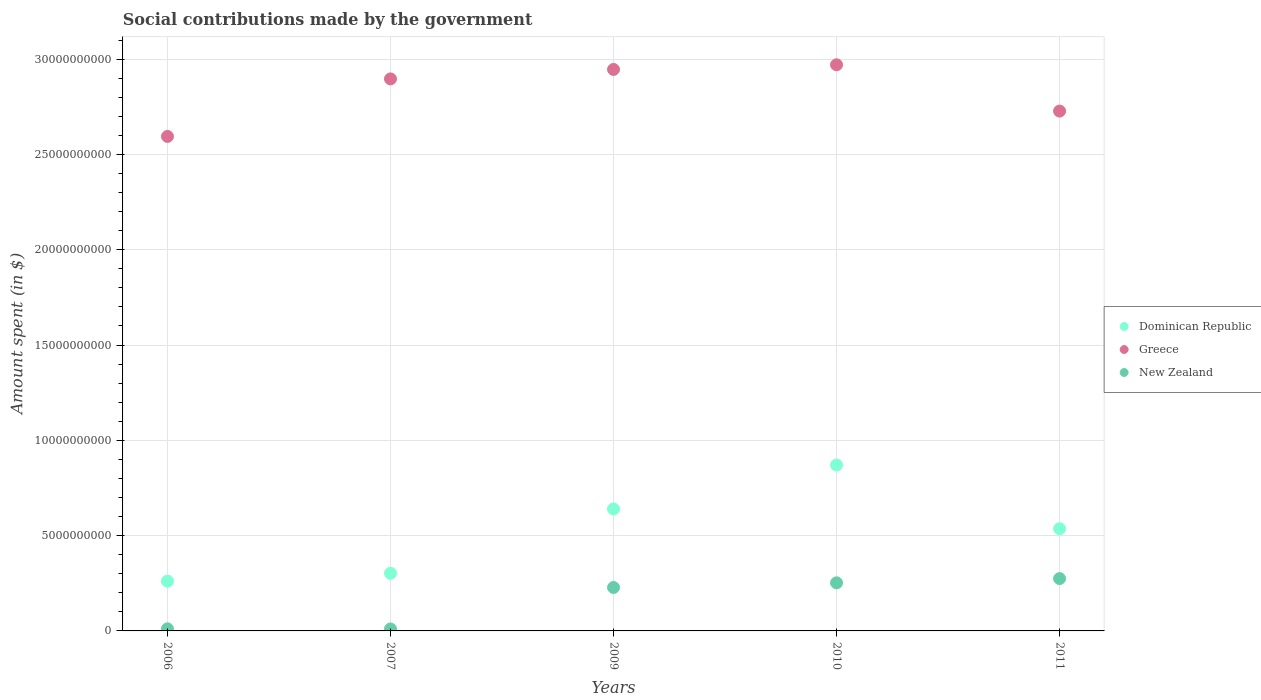Is the number of dotlines equal to the number of legend labels?
Ensure brevity in your answer.  Yes. What is the amount spent on social contributions in Greece in 2011?
Make the answer very short. 2.73e+1. Across all years, what is the maximum amount spent on social contributions in Greece?
Your answer should be very brief. 2.97e+1. Across all years, what is the minimum amount spent on social contributions in New Zealand?
Your response must be concise. 1.01e+08. In which year was the amount spent on social contributions in Greece maximum?
Make the answer very short. 2010. In which year was the amount spent on social contributions in Dominican Republic minimum?
Your answer should be very brief. 2006. What is the total amount spent on social contributions in New Zealand in the graph?
Your answer should be compact. 7.76e+09. What is the difference between the amount spent on social contributions in New Zealand in 2006 and that in 2010?
Your response must be concise. -2.41e+09. What is the difference between the amount spent on social contributions in Greece in 2011 and the amount spent on social contributions in New Zealand in 2007?
Your answer should be very brief. 2.72e+1. What is the average amount spent on social contributions in Dominican Republic per year?
Ensure brevity in your answer.  5.22e+09. In the year 2006, what is the difference between the amount spent on social contributions in New Zealand and amount spent on social contributions in Dominican Republic?
Make the answer very short. -2.50e+09. In how many years, is the amount spent on social contributions in Dominican Republic greater than 2000000000 $?
Provide a short and direct response. 5. What is the ratio of the amount spent on social contributions in Dominican Republic in 2006 to that in 2010?
Your answer should be compact. 0.3. Is the amount spent on social contributions in Greece in 2006 less than that in 2011?
Make the answer very short. Yes. What is the difference between the highest and the second highest amount spent on social contributions in New Zealand?
Offer a very short reply. 2.23e+08. What is the difference between the highest and the lowest amount spent on social contributions in New Zealand?
Offer a very short reply. 2.64e+09. Is it the case that in every year, the sum of the amount spent on social contributions in New Zealand and amount spent on social contributions in Dominican Republic  is greater than the amount spent on social contributions in Greece?
Ensure brevity in your answer.  No. Is the amount spent on social contributions in Dominican Republic strictly greater than the amount spent on social contributions in Greece over the years?
Offer a terse response. No. Does the graph contain any zero values?
Give a very brief answer. No. Where does the legend appear in the graph?
Give a very brief answer. Center right. How many legend labels are there?
Provide a short and direct response. 3. What is the title of the graph?
Provide a succinct answer. Social contributions made by the government. Does "Norway" appear as one of the legend labels in the graph?
Make the answer very short. No. What is the label or title of the X-axis?
Your answer should be very brief. Years. What is the label or title of the Y-axis?
Your response must be concise. Amount spent (in $). What is the Amount spent (in $) in Dominican Republic in 2006?
Ensure brevity in your answer.  2.61e+09. What is the Amount spent (in $) in Greece in 2006?
Offer a terse response. 2.59e+1. What is the Amount spent (in $) of New Zealand in 2006?
Offer a terse response. 1.09e+08. What is the Amount spent (in $) of Dominican Republic in 2007?
Give a very brief answer. 3.02e+09. What is the Amount spent (in $) of Greece in 2007?
Ensure brevity in your answer.  2.90e+1. What is the Amount spent (in $) in New Zealand in 2007?
Your answer should be very brief. 1.01e+08. What is the Amount spent (in $) in Dominican Republic in 2009?
Your answer should be very brief. 6.40e+09. What is the Amount spent (in $) in Greece in 2009?
Give a very brief answer. 2.95e+1. What is the Amount spent (in $) of New Zealand in 2009?
Your answer should be compact. 2.28e+09. What is the Amount spent (in $) of Dominican Republic in 2010?
Provide a succinct answer. 8.70e+09. What is the Amount spent (in $) in Greece in 2010?
Give a very brief answer. 2.97e+1. What is the Amount spent (in $) in New Zealand in 2010?
Keep it short and to the point. 2.52e+09. What is the Amount spent (in $) of Dominican Republic in 2011?
Make the answer very short. 5.36e+09. What is the Amount spent (in $) in Greece in 2011?
Your answer should be compact. 2.73e+1. What is the Amount spent (in $) in New Zealand in 2011?
Provide a short and direct response. 2.75e+09. Across all years, what is the maximum Amount spent (in $) of Dominican Republic?
Provide a short and direct response. 8.70e+09. Across all years, what is the maximum Amount spent (in $) of Greece?
Give a very brief answer. 2.97e+1. Across all years, what is the maximum Amount spent (in $) in New Zealand?
Make the answer very short. 2.75e+09. Across all years, what is the minimum Amount spent (in $) of Dominican Republic?
Ensure brevity in your answer.  2.61e+09. Across all years, what is the minimum Amount spent (in $) in Greece?
Your answer should be very brief. 2.59e+1. Across all years, what is the minimum Amount spent (in $) of New Zealand?
Your answer should be compact. 1.01e+08. What is the total Amount spent (in $) of Dominican Republic in the graph?
Ensure brevity in your answer.  2.61e+1. What is the total Amount spent (in $) of Greece in the graph?
Provide a succinct answer. 1.41e+11. What is the total Amount spent (in $) in New Zealand in the graph?
Provide a short and direct response. 7.76e+09. What is the difference between the Amount spent (in $) of Dominican Republic in 2006 and that in 2007?
Provide a short and direct response. -4.13e+08. What is the difference between the Amount spent (in $) of Greece in 2006 and that in 2007?
Ensure brevity in your answer.  -3.02e+09. What is the difference between the Amount spent (in $) of New Zealand in 2006 and that in 2007?
Provide a succinct answer. 8.00e+06. What is the difference between the Amount spent (in $) in Dominican Republic in 2006 and that in 2009?
Provide a short and direct response. -3.79e+09. What is the difference between the Amount spent (in $) of Greece in 2006 and that in 2009?
Provide a succinct answer. -3.51e+09. What is the difference between the Amount spent (in $) in New Zealand in 2006 and that in 2009?
Offer a very short reply. -2.17e+09. What is the difference between the Amount spent (in $) of Dominican Republic in 2006 and that in 2010?
Provide a succinct answer. -6.09e+09. What is the difference between the Amount spent (in $) of Greece in 2006 and that in 2010?
Give a very brief answer. -3.76e+09. What is the difference between the Amount spent (in $) in New Zealand in 2006 and that in 2010?
Your answer should be compact. -2.41e+09. What is the difference between the Amount spent (in $) of Dominican Republic in 2006 and that in 2011?
Offer a very short reply. -2.75e+09. What is the difference between the Amount spent (in $) of Greece in 2006 and that in 2011?
Offer a terse response. -1.33e+09. What is the difference between the Amount spent (in $) of New Zealand in 2006 and that in 2011?
Your answer should be very brief. -2.64e+09. What is the difference between the Amount spent (in $) of Dominican Republic in 2007 and that in 2009?
Offer a very short reply. -3.37e+09. What is the difference between the Amount spent (in $) in Greece in 2007 and that in 2009?
Give a very brief answer. -4.96e+08. What is the difference between the Amount spent (in $) in New Zealand in 2007 and that in 2009?
Offer a terse response. -2.18e+09. What is the difference between the Amount spent (in $) in Dominican Republic in 2007 and that in 2010?
Provide a short and direct response. -5.68e+09. What is the difference between the Amount spent (in $) in Greece in 2007 and that in 2010?
Provide a short and direct response. -7.40e+08. What is the difference between the Amount spent (in $) of New Zealand in 2007 and that in 2010?
Your response must be concise. -2.42e+09. What is the difference between the Amount spent (in $) in Dominican Republic in 2007 and that in 2011?
Your response must be concise. -2.34e+09. What is the difference between the Amount spent (in $) in Greece in 2007 and that in 2011?
Give a very brief answer. 1.69e+09. What is the difference between the Amount spent (in $) of New Zealand in 2007 and that in 2011?
Make the answer very short. -2.64e+09. What is the difference between the Amount spent (in $) in Dominican Republic in 2009 and that in 2010?
Provide a succinct answer. -2.31e+09. What is the difference between the Amount spent (in $) of Greece in 2009 and that in 2010?
Your answer should be very brief. -2.44e+08. What is the difference between the Amount spent (in $) in New Zealand in 2009 and that in 2010?
Make the answer very short. -2.44e+08. What is the difference between the Amount spent (in $) in Dominican Republic in 2009 and that in 2011?
Offer a very short reply. 1.04e+09. What is the difference between the Amount spent (in $) in Greece in 2009 and that in 2011?
Your response must be concise. 2.18e+09. What is the difference between the Amount spent (in $) of New Zealand in 2009 and that in 2011?
Make the answer very short. -4.67e+08. What is the difference between the Amount spent (in $) in Dominican Republic in 2010 and that in 2011?
Offer a very short reply. 3.34e+09. What is the difference between the Amount spent (in $) in Greece in 2010 and that in 2011?
Offer a terse response. 2.43e+09. What is the difference between the Amount spent (in $) in New Zealand in 2010 and that in 2011?
Keep it short and to the point. -2.23e+08. What is the difference between the Amount spent (in $) in Dominican Republic in 2006 and the Amount spent (in $) in Greece in 2007?
Your answer should be very brief. -2.63e+1. What is the difference between the Amount spent (in $) of Dominican Republic in 2006 and the Amount spent (in $) of New Zealand in 2007?
Provide a short and direct response. 2.51e+09. What is the difference between the Amount spent (in $) in Greece in 2006 and the Amount spent (in $) in New Zealand in 2007?
Keep it short and to the point. 2.58e+1. What is the difference between the Amount spent (in $) of Dominican Republic in 2006 and the Amount spent (in $) of Greece in 2009?
Ensure brevity in your answer.  -2.68e+1. What is the difference between the Amount spent (in $) of Dominican Republic in 2006 and the Amount spent (in $) of New Zealand in 2009?
Provide a short and direct response. 3.33e+08. What is the difference between the Amount spent (in $) in Greece in 2006 and the Amount spent (in $) in New Zealand in 2009?
Keep it short and to the point. 2.37e+1. What is the difference between the Amount spent (in $) in Dominican Republic in 2006 and the Amount spent (in $) in Greece in 2010?
Your response must be concise. -2.71e+1. What is the difference between the Amount spent (in $) of Dominican Republic in 2006 and the Amount spent (in $) of New Zealand in 2010?
Provide a succinct answer. 8.89e+07. What is the difference between the Amount spent (in $) of Greece in 2006 and the Amount spent (in $) of New Zealand in 2010?
Provide a succinct answer. 2.34e+1. What is the difference between the Amount spent (in $) of Dominican Republic in 2006 and the Amount spent (in $) of Greece in 2011?
Make the answer very short. -2.47e+1. What is the difference between the Amount spent (in $) in Dominican Republic in 2006 and the Amount spent (in $) in New Zealand in 2011?
Provide a short and direct response. -1.34e+08. What is the difference between the Amount spent (in $) in Greece in 2006 and the Amount spent (in $) in New Zealand in 2011?
Make the answer very short. 2.32e+1. What is the difference between the Amount spent (in $) of Dominican Republic in 2007 and the Amount spent (in $) of Greece in 2009?
Make the answer very short. -2.64e+1. What is the difference between the Amount spent (in $) in Dominican Republic in 2007 and the Amount spent (in $) in New Zealand in 2009?
Your answer should be compact. 7.46e+08. What is the difference between the Amount spent (in $) in Greece in 2007 and the Amount spent (in $) in New Zealand in 2009?
Provide a short and direct response. 2.67e+1. What is the difference between the Amount spent (in $) in Dominican Republic in 2007 and the Amount spent (in $) in Greece in 2010?
Give a very brief answer. -2.67e+1. What is the difference between the Amount spent (in $) in Dominican Republic in 2007 and the Amount spent (in $) in New Zealand in 2010?
Ensure brevity in your answer.  5.02e+08. What is the difference between the Amount spent (in $) of Greece in 2007 and the Amount spent (in $) of New Zealand in 2010?
Offer a very short reply. 2.64e+1. What is the difference between the Amount spent (in $) of Dominican Republic in 2007 and the Amount spent (in $) of Greece in 2011?
Provide a short and direct response. -2.42e+1. What is the difference between the Amount spent (in $) of Dominican Republic in 2007 and the Amount spent (in $) of New Zealand in 2011?
Offer a terse response. 2.79e+08. What is the difference between the Amount spent (in $) of Greece in 2007 and the Amount spent (in $) of New Zealand in 2011?
Your answer should be compact. 2.62e+1. What is the difference between the Amount spent (in $) in Dominican Republic in 2009 and the Amount spent (in $) in Greece in 2010?
Your response must be concise. -2.33e+1. What is the difference between the Amount spent (in $) of Dominican Republic in 2009 and the Amount spent (in $) of New Zealand in 2010?
Offer a very short reply. 3.88e+09. What is the difference between the Amount spent (in $) of Greece in 2009 and the Amount spent (in $) of New Zealand in 2010?
Provide a short and direct response. 2.69e+1. What is the difference between the Amount spent (in $) in Dominican Republic in 2009 and the Amount spent (in $) in Greece in 2011?
Provide a short and direct response. -2.09e+1. What is the difference between the Amount spent (in $) of Dominican Republic in 2009 and the Amount spent (in $) of New Zealand in 2011?
Offer a terse response. 3.65e+09. What is the difference between the Amount spent (in $) of Greece in 2009 and the Amount spent (in $) of New Zealand in 2011?
Provide a short and direct response. 2.67e+1. What is the difference between the Amount spent (in $) in Dominican Republic in 2010 and the Amount spent (in $) in Greece in 2011?
Keep it short and to the point. -1.86e+1. What is the difference between the Amount spent (in $) in Dominican Republic in 2010 and the Amount spent (in $) in New Zealand in 2011?
Your response must be concise. 5.96e+09. What is the difference between the Amount spent (in $) of Greece in 2010 and the Amount spent (in $) of New Zealand in 2011?
Provide a succinct answer. 2.70e+1. What is the average Amount spent (in $) in Dominican Republic per year?
Your answer should be very brief. 5.22e+09. What is the average Amount spent (in $) in Greece per year?
Keep it short and to the point. 2.83e+1. What is the average Amount spent (in $) of New Zealand per year?
Offer a terse response. 1.55e+09. In the year 2006, what is the difference between the Amount spent (in $) in Dominican Republic and Amount spent (in $) in Greece?
Offer a terse response. -2.33e+1. In the year 2006, what is the difference between the Amount spent (in $) of Dominican Republic and Amount spent (in $) of New Zealand?
Your answer should be compact. 2.50e+09. In the year 2006, what is the difference between the Amount spent (in $) of Greece and Amount spent (in $) of New Zealand?
Your response must be concise. 2.58e+1. In the year 2007, what is the difference between the Amount spent (in $) of Dominican Republic and Amount spent (in $) of Greece?
Keep it short and to the point. -2.59e+1. In the year 2007, what is the difference between the Amount spent (in $) in Dominican Republic and Amount spent (in $) in New Zealand?
Provide a short and direct response. 2.92e+09. In the year 2007, what is the difference between the Amount spent (in $) in Greece and Amount spent (in $) in New Zealand?
Offer a terse response. 2.89e+1. In the year 2009, what is the difference between the Amount spent (in $) of Dominican Republic and Amount spent (in $) of Greece?
Make the answer very short. -2.31e+1. In the year 2009, what is the difference between the Amount spent (in $) in Dominican Republic and Amount spent (in $) in New Zealand?
Your response must be concise. 4.12e+09. In the year 2009, what is the difference between the Amount spent (in $) in Greece and Amount spent (in $) in New Zealand?
Your answer should be compact. 2.72e+1. In the year 2010, what is the difference between the Amount spent (in $) in Dominican Republic and Amount spent (in $) in Greece?
Your response must be concise. -2.10e+1. In the year 2010, what is the difference between the Amount spent (in $) of Dominican Republic and Amount spent (in $) of New Zealand?
Offer a very short reply. 6.18e+09. In the year 2010, what is the difference between the Amount spent (in $) of Greece and Amount spent (in $) of New Zealand?
Make the answer very short. 2.72e+1. In the year 2011, what is the difference between the Amount spent (in $) in Dominican Republic and Amount spent (in $) in Greece?
Provide a short and direct response. -2.19e+1. In the year 2011, what is the difference between the Amount spent (in $) in Dominican Republic and Amount spent (in $) in New Zealand?
Offer a very short reply. 2.61e+09. In the year 2011, what is the difference between the Amount spent (in $) of Greece and Amount spent (in $) of New Zealand?
Make the answer very short. 2.45e+1. What is the ratio of the Amount spent (in $) of Dominican Republic in 2006 to that in 2007?
Provide a succinct answer. 0.86. What is the ratio of the Amount spent (in $) of Greece in 2006 to that in 2007?
Ensure brevity in your answer.  0.9. What is the ratio of the Amount spent (in $) in New Zealand in 2006 to that in 2007?
Give a very brief answer. 1.08. What is the ratio of the Amount spent (in $) of Dominican Republic in 2006 to that in 2009?
Your response must be concise. 0.41. What is the ratio of the Amount spent (in $) of Greece in 2006 to that in 2009?
Give a very brief answer. 0.88. What is the ratio of the Amount spent (in $) of New Zealand in 2006 to that in 2009?
Make the answer very short. 0.05. What is the ratio of the Amount spent (in $) in Greece in 2006 to that in 2010?
Your answer should be very brief. 0.87. What is the ratio of the Amount spent (in $) of New Zealand in 2006 to that in 2010?
Offer a very short reply. 0.04. What is the ratio of the Amount spent (in $) of Dominican Republic in 2006 to that in 2011?
Provide a short and direct response. 0.49. What is the ratio of the Amount spent (in $) of Greece in 2006 to that in 2011?
Offer a very short reply. 0.95. What is the ratio of the Amount spent (in $) of New Zealand in 2006 to that in 2011?
Offer a terse response. 0.04. What is the ratio of the Amount spent (in $) in Dominican Republic in 2007 to that in 2009?
Your answer should be compact. 0.47. What is the ratio of the Amount spent (in $) in Greece in 2007 to that in 2009?
Provide a short and direct response. 0.98. What is the ratio of the Amount spent (in $) in New Zealand in 2007 to that in 2009?
Offer a very short reply. 0.04. What is the ratio of the Amount spent (in $) in Dominican Republic in 2007 to that in 2010?
Provide a short and direct response. 0.35. What is the ratio of the Amount spent (in $) of Greece in 2007 to that in 2010?
Give a very brief answer. 0.98. What is the ratio of the Amount spent (in $) in New Zealand in 2007 to that in 2010?
Provide a short and direct response. 0.04. What is the ratio of the Amount spent (in $) of Dominican Republic in 2007 to that in 2011?
Your answer should be very brief. 0.56. What is the ratio of the Amount spent (in $) in Greece in 2007 to that in 2011?
Provide a short and direct response. 1.06. What is the ratio of the Amount spent (in $) of New Zealand in 2007 to that in 2011?
Ensure brevity in your answer.  0.04. What is the ratio of the Amount spent (in $) of Dominican Republic in 2009 to that in 2010?
Offer a very short reply. 0.74. What is the ratio of the Amount spent (in $) in New Zealand in 2009 to that in 2010?
Provide a short and direct response. 0.9. What is the ratio of the Amount spent (in $) in Dominican Republic in 2009 to that in 2011?
Offer a very short reply. 1.19. What is the ratio of the Amount spent (in $) of Greece in 2009 to that in 2011?
Make the answer very short. 1.08. What is the ratio of the Amount spent (in $) in New Zealand in 2009 to that in 2011?
Offer a very short reply. 0.83. What is the ratio of the Amount spent (in $) in Dominican Republic in 2010 to that in 2011?
Ensure brevity in your answer.  1.62. What is the ratio of the Amount spent (in $) in Greece in 2010 to that in 2011?
Your answer should be compact. 1.09. What is the ratio of the Amount spent (in $) of New Zealand in 2010 to that in 2011?
Offer a very short reply. 0.92. What is the difference between the highest and the second highest Amount spent (in $) of Dominican Republic?
Ensure brevity in your answer.  2.31e+09. What is the difference between the highest and the second highest Amount spent (in $) in Greece?
Your response must be concise. 2.44e+08. What is the difference between the highest and the second highest Amount spent (in $) in New Zealand?
Your answer should be compact. 2.23e+08. What is the difference between the highest and the lowest Amount spent (in $) in Dominican Republic?
Make the answer very short. 6.09e+09. What is the difference between the highest and the lowest Amount spent (in $) in Greece?
Your response must be concise. 3.76e+09. What is the difference between the highest and the lowest Amount spent (in $) of New Zealand?
Your answer should be very brief. 2.64e+09. 